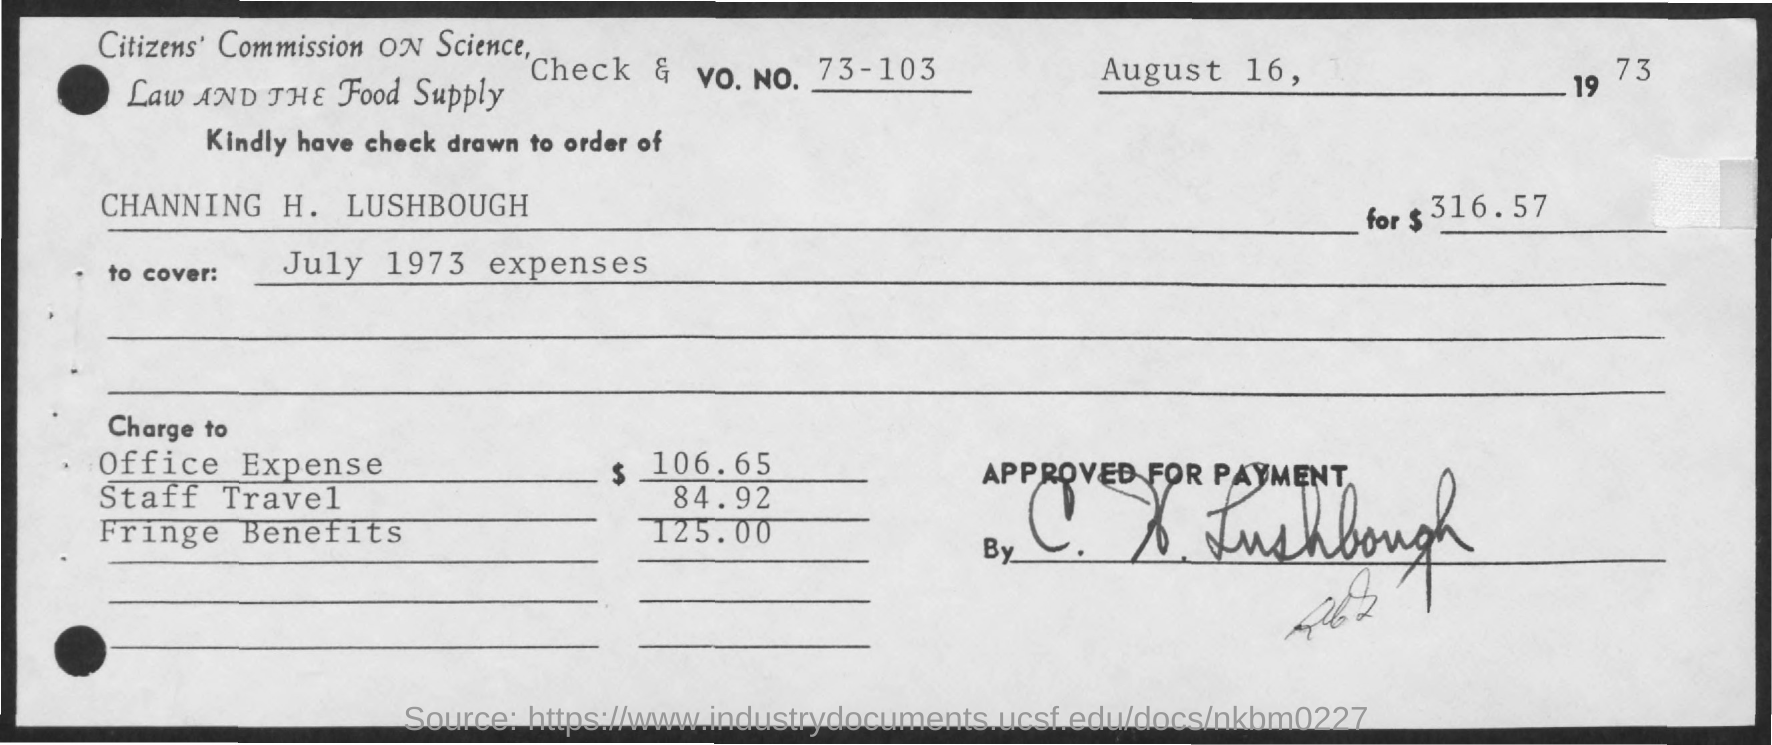What is the date mentioned in the given check?
Give a very brief answer. AUGUST 16,1973. What are the office expenses mentioned in the given check ?
Offer a very short reply. $ 106.65. What is the amount of staff travel mentioned in the given check ?
Give a very brief answer. 84.92. What is the amount of fringe benefits as mentioned in the given check ?
Keep it short and to the point. $ 125.00. What is the check & vo.no. given ?
Your answer should be very brief. 73-103. 